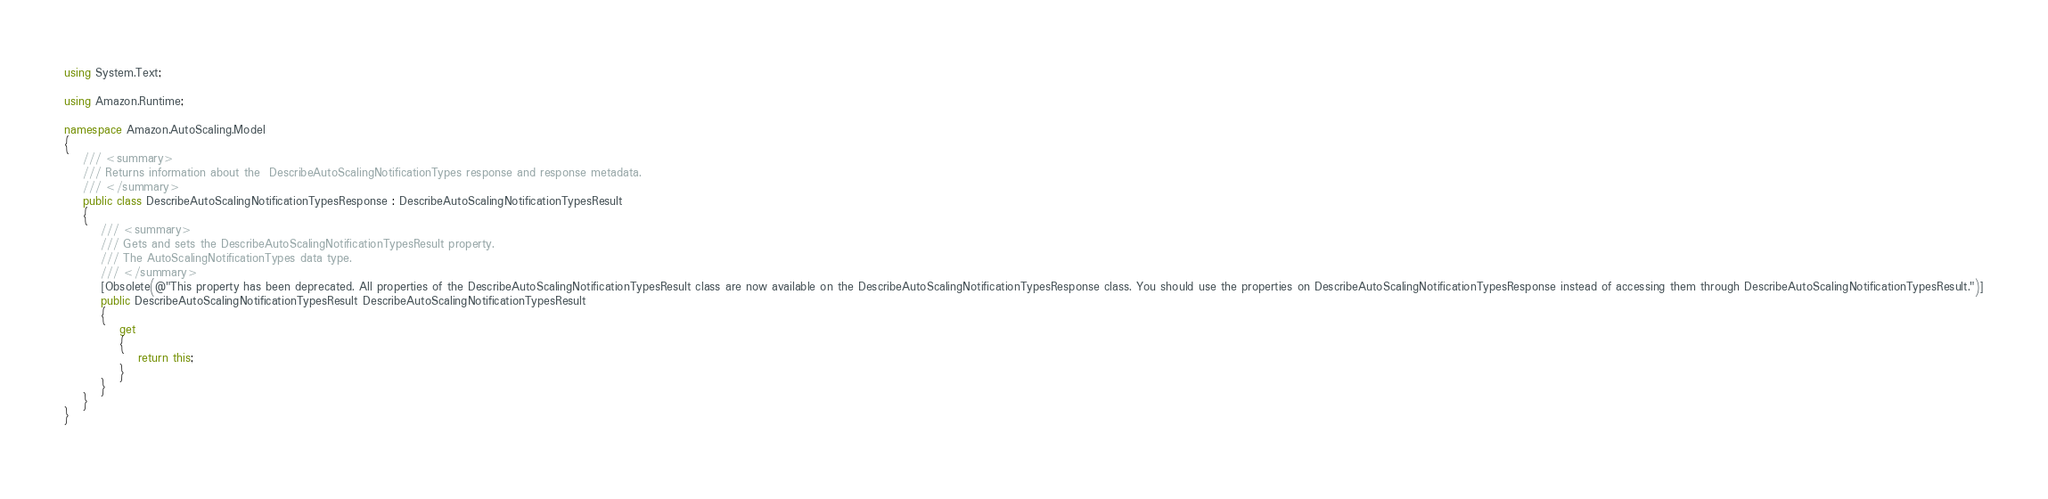<code> <loc_0><loc_0><loc_500><loc_500><_C#_>using System.Text;

using Amazon.Runtime;

namespace Amazon.AutoScaling.Model
{
    /// <summary>
    /// Returns information about the  DescribeAutoScalingNotificationTypes response and response metadata.
    /// </summary>
    public class DescribeAutoScalingNotificationTypesResponse : DescribeAutoScalingNotificationTypesResult
    {
        /// <summary>
        /// Gets and sets the DescribeAutoScalingNotificationTypesResult property.
        /// The AutoScalingNotificationTypes data type.
        /// </summary>
        [Obsolete(@"This property has been deprecated. All properties of the DescribeAutoScalingNotificationTypesResult class are now available on the DescribeAutoScalingNotificationTypesResponse class. You should use the properties on DescribeAutoScalingNotificationTypesResponse instead of accessing them through DescribeAutoScalingNotificationTypesResult.")]
        public DescribeAutoScalingNotificationTypesResult DescribeAutoScalingNotificationTypesResult
        {
            get
            {
                return this;
            }
        }
    }
}
    
</code> 